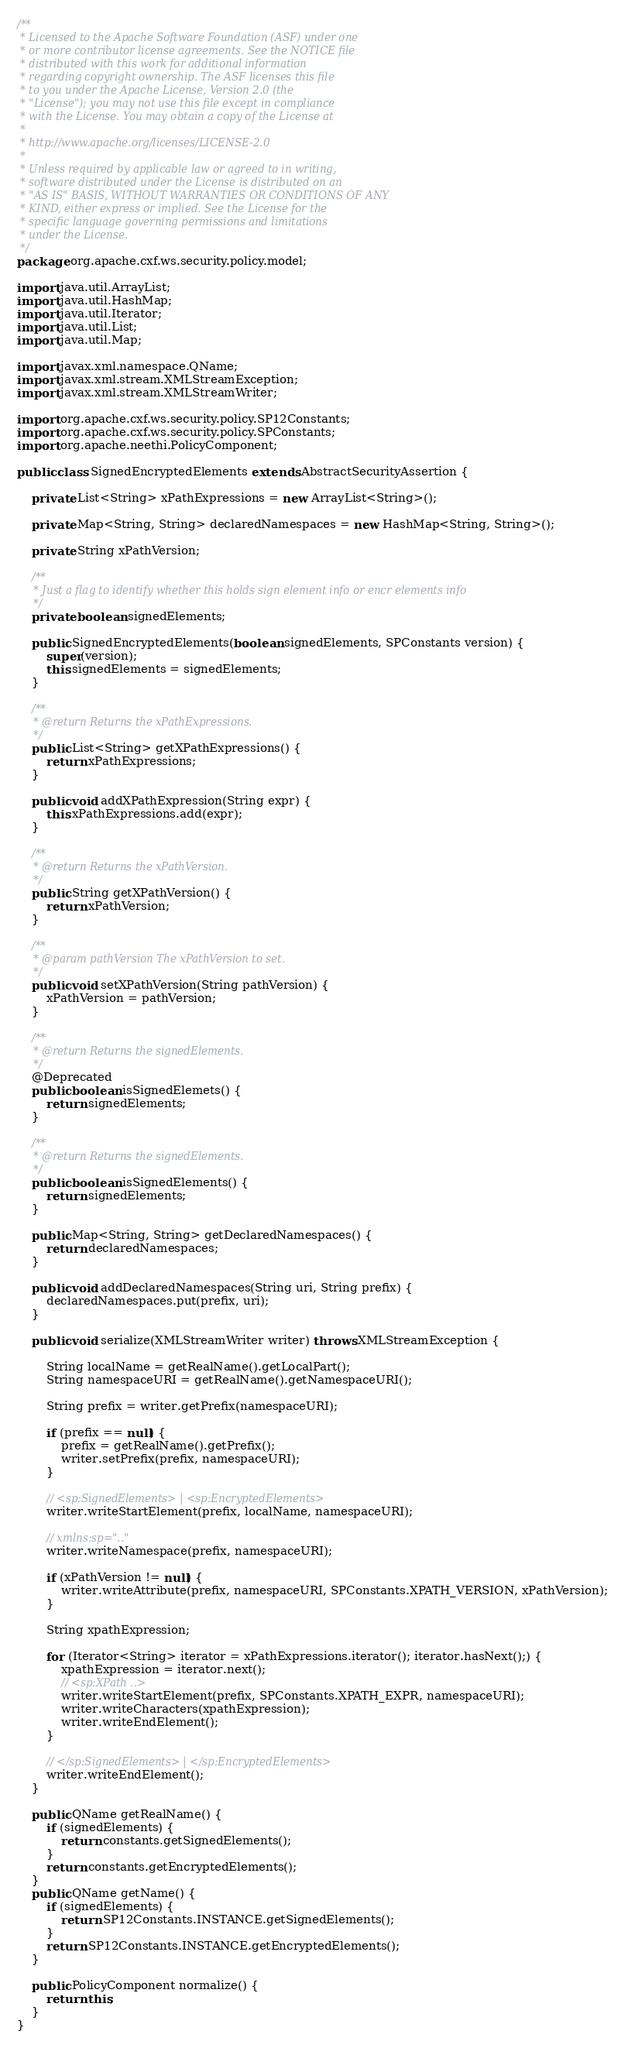Convert code to text. <code><loc_0><loc_0><loc_500><loc_500><_Java_>/**
 * Licensed to the Apache Software Foundation (ASF) under one
 * or more contributor license agreements. See the NOTICE file
 * distributed with this work for additional information
 * regarding copyright ownership. The ASF licenses this file
 * to you under the Apache License, Version 2.0 (the
 * "License"); you may not use this file except in compliance
 * with the License. You may obtain a copy of the License at
 *
 * http://www.apache.org/licenses/LICENSE-2.0
 *
 * Unless required by applicable law or agreed to in writing,
 * software distributed under the License is distributed on an
 * "AS IS" BASIS, WITHOUT WARRANTIES OR CONDITIONS OF ANY
 * KIND, either express or implied. See the License for the
 * specific language governing permissions and limitations
 * under the License.
 */
package org.apache.cxf.ws.security.policy.model;

import java.util.ArrayList;
import java.util.HashMap;
import java.util.Iterator;
import java.util.List;
import java.util.Map;

import javax.xml.namespace.QName;
import javax.xml.stream.XMLStreamException;
import javax.xml.stream.XMLStreamWriter;

import org.apache.cxf.ws.security.policy.SP12Constants;
import org.apache.cxf.ws.security.policy.SPConstants;
import org.apache.neethi.PolicyComponent;

public class SignedEncryptedElements extends AbstractSecurityAssertion {

    private List<String> xPathExpressions = new ArrayList<String>();

    private Map<String, String> declaredNamespaces = new HashMap<String, String>();

    private String xPathVersion;

    /**
     * Just a flag to identify whether this holds sign element info or encr elements info
     */
    private boolean signedElements;

    public SignedEncryptedElements(boolean signedElements, SPConstants version) {
        super(version);
        this.signedElements = signedElements;
    }

    /**
     * @return Returns the xPathExpressions.
     */
    public List<String> getXPathExpressions() {
        return xPathExpressions;
    }

    public void addXPathExpression(String expr) {
        this.xPathExpressions.add(expr);
    }

    /**
     * @return Returns the xPathVersion.
     */
    public String getXPathVersion() {
        return xPathVersion;
    }

    /**
     * @param pathVersion The xPathVersion to set.
     */
    public void setXPathVersion(String pathVersion) {
        xPathVersion = pathVersion;
    }

    /**
     * @return Returns the signedElements.
     */
    @Deprecated
    public boolean isSignedElemets() {
        return signedElements;
    }
    
    /**
     * @return Returns the signedElements.
     */
    public boolean isSignedElements() {
        return signedElements;
    }

    public Map<String, String> getDeclaredNamespaces() {
        return declaredNamespaces;
    }

    public void addDeclaredNamespaces(String uri, String prefix) {
        declaredNamespaces.put(prefix, uri);
    }

    public void serialize(XMLStreamWriter writer) throws XMLStreamException {

        String localName = getRealName().getLocalPart();
        String namespaceURI = getRealName().getNamespaceURI();

        String prefix = writer.getPrefix(namespaceURI);

        if (prefix == null) {
            prefix = getRealName().getPrefix();
            writer.setPrefix(prefix, namespaceURI);
        }

        // <sp:SignedElements> | <sp:EncryptedElements>
        writer.writeStartElement(prefix, localName, namespaceURI);

        // xmlns:sp=".."
        writer.writeNamespace(prefix, namespaceURI);

        if (xPathVersion != null) {
            writer.writeAttribute(prefix, namespaceURI, SPConstants.XPATH_VERSION, xPathVersion);
        }

        String xpathExpression;

        for (Iterator<String> iterator = xPathExpressions.iterator(); iterator.hasNext();) {
            xpathExpression = iterator.next();
            // <sp:XPath ..>
            writer.writeStartElement(prefix, SPConstants.XPATH_EXPR, namespaceURI);
            writer.writeCharacters(xpathExpression);
            writer.writeEndElement();
        }

        // </sp:SignedElements> | </sp:EncryptedElements>
        writer.writeEndElement();
    }

    public QName getRealName() {
        if (signedElements) {
            return constants.getSignedElements();
        }
        return constants.getEncryptedElements();
    }
    public QName getName() {
        if (signedElements) {
            return SP12Constants.INSTANCE.getSignedElements();
        }
        return SP12Constants.INSTANCE.getEncryptedElements();
    }

    public PolicyComponent normalize() {
        return this;
    }
}
</code> 